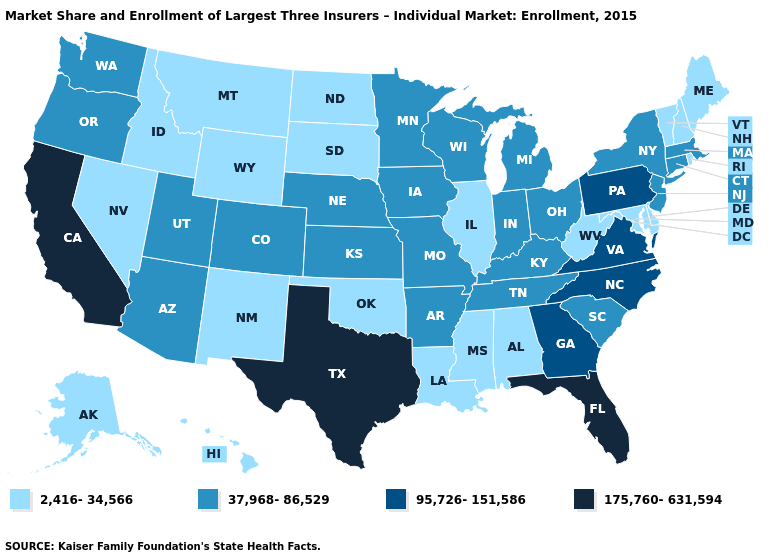Name the states that have a value in the range 175,760-631,594?
Short answer required. California, Florida, Texas. How many symbols are there in the legend?
Short answer required. 4. What is the value of Indiana?
Concise answer only. 37,968-86,529. Which states have the lowest value in the USA?
Be succinct. Alabama, Alaska, Delaware, Hawaii, Idaho, Illinois, Louisiana, Maine, Maryland, Mississippi, Montana, Nevada, New Hampshire, New Mexico, North Dakota, Oklahoma, Rhode Island, South Dakota, Vermont, West Virginia, Wyoming. Among the states that border Oregon , does Nevada have the lowest value?
Write a very short answer. Yes. What is the value of Montana?
Concise answer only. 2,416-34,566. Among the states that border Oklahoma , does Texas have the highest value?
Short answer required. Yes. Name the states that have a value in the range 2,416-34,566?
Be succinct. Alabama, Alaska, Delaware, Hawaii, Idaho, Illinois, Louisiana, Maine, Maryland, Mississippi, Montana, Nevada, New Hampshire, New Mexico, North Dakota, Oklahoma, Rhode Island, South Dakota, Vermont, West Virginia, Wyoming. What is the value of Maryland?
Be succinct. 2,416-34,566. What is the lowest value in the MidWest?
Answer briefly. 2,416-34,566. How many symbols are there in the legend?
Concise answer only. 4. Is the legend a continuous bar?
Quick response, please. No. What is the highest value in the USA?
Short answer required. 175,760-631,594. Name the states that have a value in the range 175,760-631,594?
Be succinct. California, Florida, Texas. Which states have the highest value in the USA?
Give a very brief answer. California, Florida, Texas. 